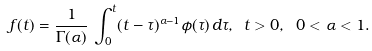<formula> <loc_0><loc_0><loc_500><loc_500>f ( t ) = \frac { 1 } { \Gamma ( \alpha ) } \, \int _ { 0 } ^ { t } ( t - \tau ) ^ { \alpha - 1 } \phi ( \tau ) \, d \tau , \ t > 0 , \ 0 < \alpha < 1 .</formula> 